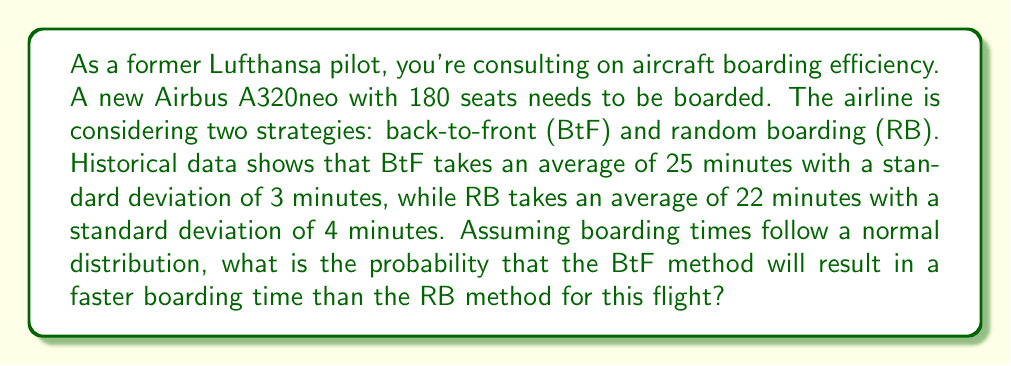Solve this math problem. To solve this problem, we need to compare the two boarding methods using their probability distributions. Let's approach this step-by-step:

1) Let $X$ be the time for Back-to-Front (BtF) boarding:
   $X \sim N(\mu_X = 25, \sigma_X = 3)$

2) Let $Y$ be the time for Random Boarding (RB):
   $Y \sim N(\mu_Y = 22, \sigma_Y = 4)$

3) We want to find $P(X < Y)$, the probability that BtF is faster than RB.

4) To do this, we can consider the difference $Z = Y - X$. If this difference is positive, it means Y is larger than X, or in other words, BtF is faster.

5) The difference of two normally distributed variables is also normally distributed:
   $Z = Y - X \sim N(\mu_Z, \sigma_Z)$

   Where:
   $\mu_Z = \mu_Y - \mu_X = 22 - 25 = -3$
   $\sigma_Z = \sqrt{\sigma_Y^2 + \sigma_X^2} = \sqrt{4^2 + 3^2} = 5$

6) So, $Z \sim N(-3, 5)$

7) We want to find $P(Z > 0)$, which is equivalent to $P(X < Y)$

8) To standardize this, we calculate the z-score:
   $z = \frac{0 - \mu_Z}{\sigma_Z} = \frac{0 - (-3)}{5} = 0.6$

9) Using a standard normal distribution table or calculator, we can find:
   $P(Z > 0) = P(Z > 0.6) = 1 - P(Z < 0.6) = 1 - 0.7257 = 0.2743$

Therefore, the probability that the Back-to-Front method will be faster than the Random Boarding method is approximately 0.2743 or 27.43%.
Answer: 0.2743 or 27.43% 